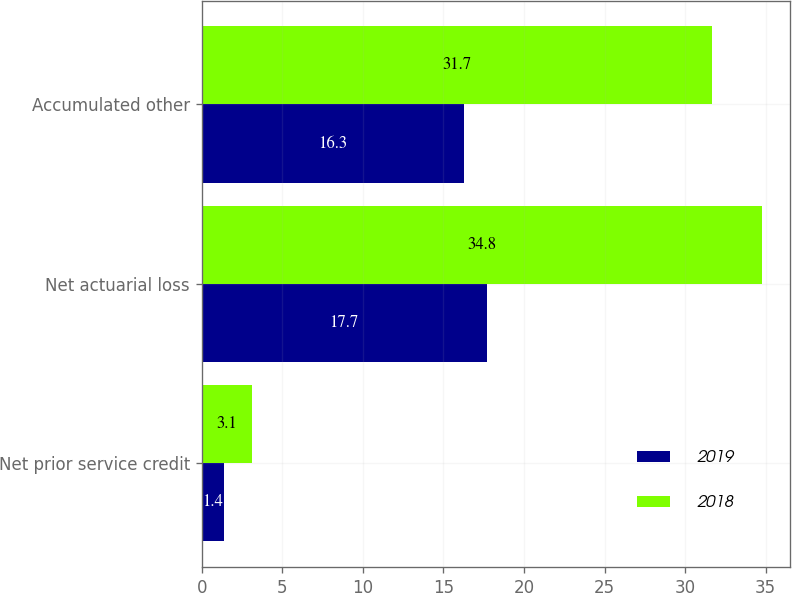Convert chart. <chart><loc_0><loc_0><loc_500><loc_500><stacked_bar_chart><ecel><fcel>Net prior service credit<fcel>Net actuarial loss<fcel>Accumulated other<nl><fcel>2019<fcel>1.4<fcel>17.7<fcel>16.3<nl><fcel>2018<fcel>3.1<fcel>34.8<fcel>31.7<nl></chart> 